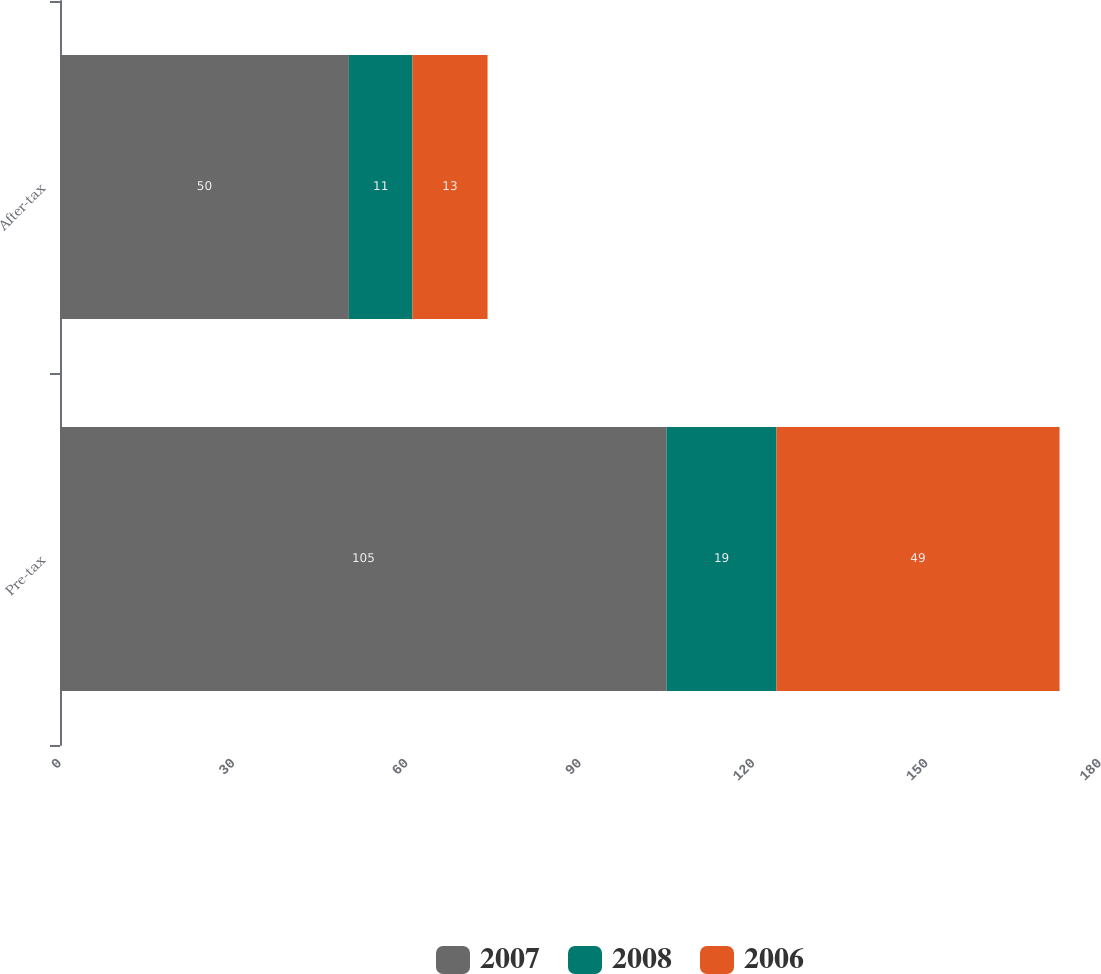Convert chart. <chart><loc_0><loc_0><loc_500><loc_500><stacked_bar_chart><ecel><fcel>Pre-tax<fcel>After-tax<nl><fcel>2007<fcel>105<fcel>50<nl><fcel>2008<fcel>19<fcel>11<nl><fcel>2006<fcel>49<fcel>13<nl></chart> 